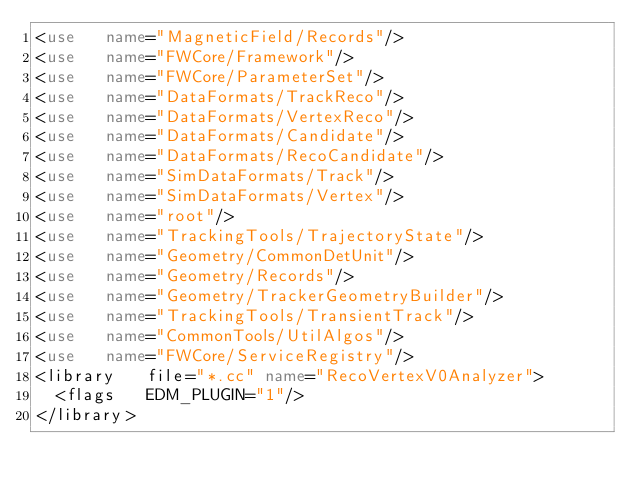<code> <loc_0><loc_0><loc_500><loc_500><_XML_><use   name="MagneticField/Records"/>
<use   name="FWCore/Framework"/>
<use   name="FWCore/ParameterSet"/>
<use   name="DataFormats/TrackReco"/>
<use   name="DataFormats/VertexReco"/>
<use   name="DataFormats/Candidate"/>
<use   name="DataFormats/RecoCandidate"/>
<use   name="SimDataFormats/Track"/>
<use   name="SimDataFormats/Vertex"/>
<use   name="root"/>
<use   name="TrackingTools/TrajectoryState"/>
<use   name="Geometry/CommonDetUnit"/>
<use   name="Geometry/Records"/>
<use   name="Geometry/TrackerGeometryBuilder"/>
<use   name="TrackingTools/TransientTrack"/>
<use   name="CommonTools/UtilAlgos"/>
<use   name="FWCore/ServiceRegistry"/>
<library   file="*.cc" name="RecoVertexV0Analyzer">
  <flags   EDM_PLUGIN="1"/>
</library>
</code> 